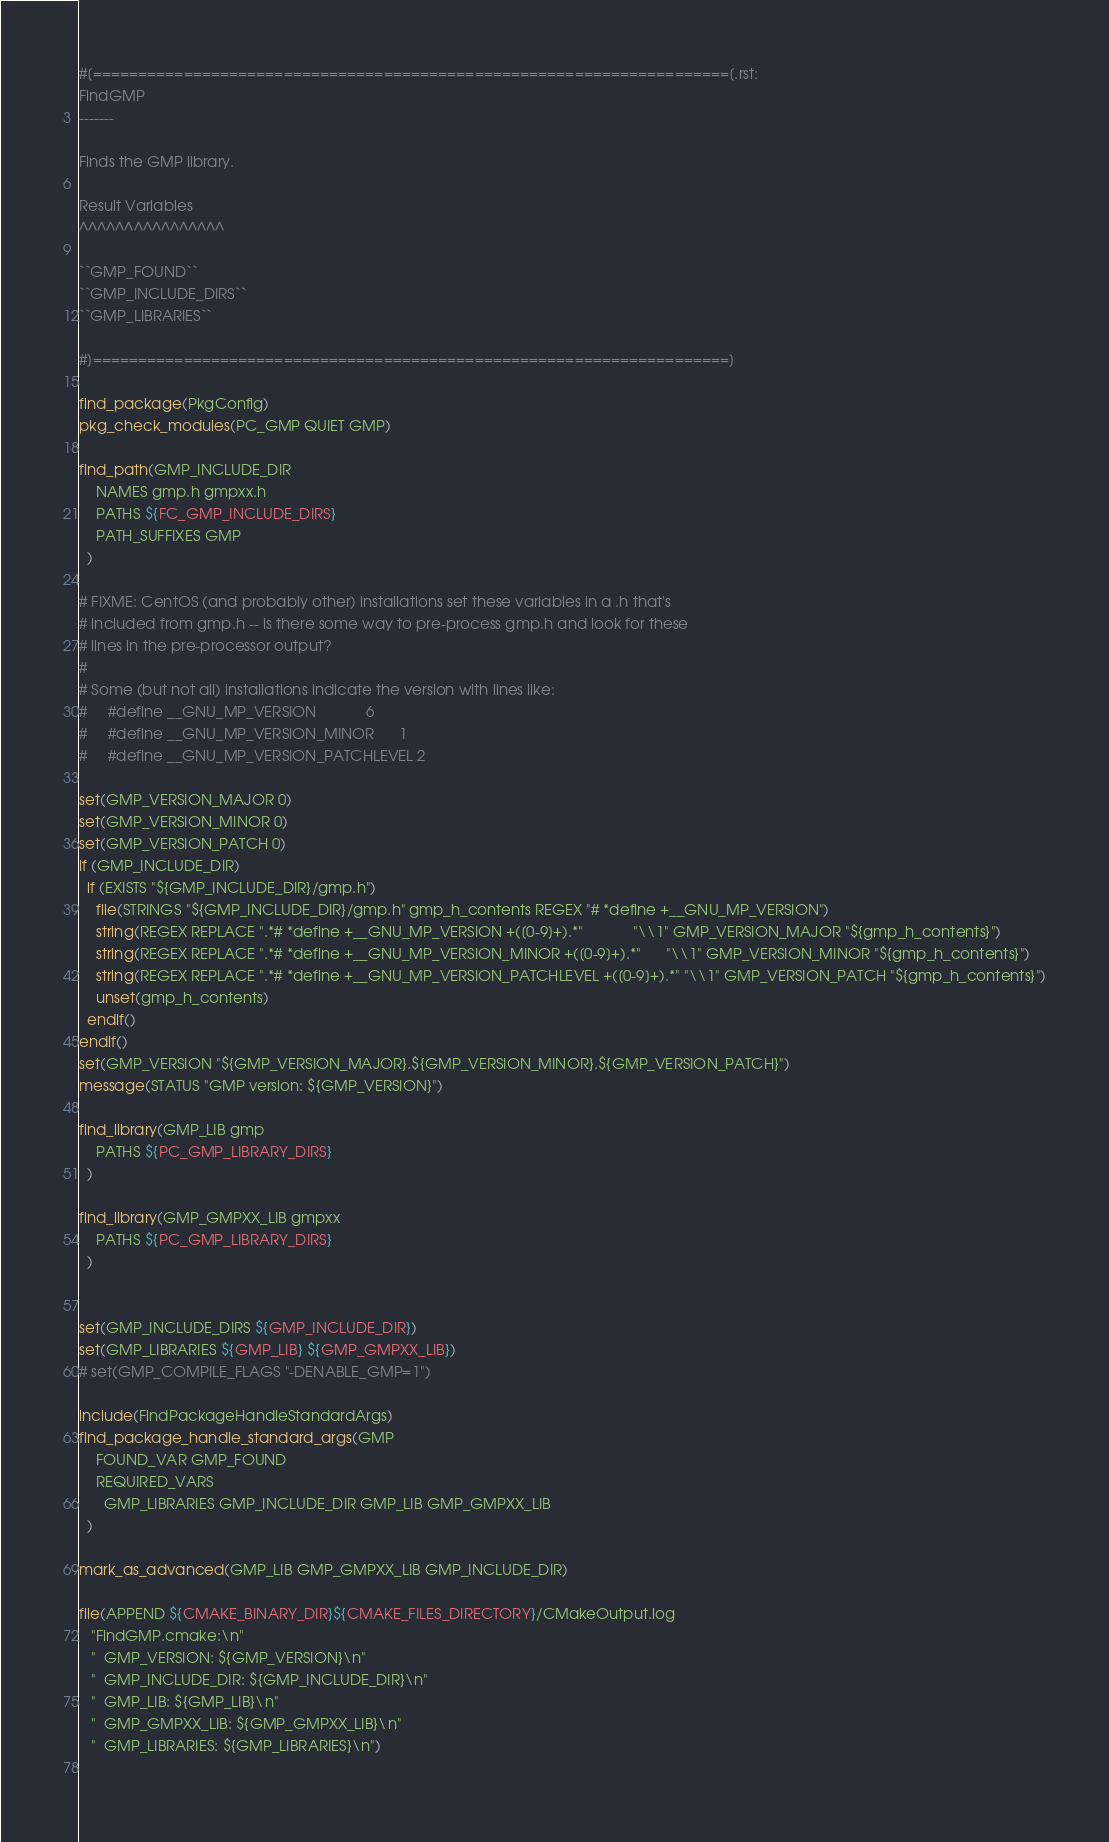Convert code to text. <code><loc_0><loc_0><loc_500><loc_500><_CMake_>#[======================================================================[.rst:
FindGMP
-------

Finds the GMP library.

Result Variables
^^^^^^^^^^^^^^^^

``GMP_FOUND``
``GMP_INCLUDE_DIRS``
``GMP_LIBRARIES``

#]======================================================================]

find_package(PkgConfig)
pkg_check_modules(PC_GMP QUIET GMP)

find_path(GMP_INCLUDE_DIR
    NAMES gmp.h gmpxx.h
    PATHS ${FC_GMP_INCLUDE_DIRS}
    PATH_SUFFIXES GMP
  )

# FIXME: CentOS (and probably other) installations set these variables in a .h that's
# included from gmp.h -- is there some way to pre-process gmp.h and look for these
# lines in the pre-processor output?
#
# Some (but not all) installations indicate the version with lines like:
#     #define __GNU_MP_VERSION            6
#     #define __GNU_MP_VERSION_MINOR      1
#     #define __GNU_MP_VERSION_PATCHLEVEL 2

set(GMP_VERSION_MAJOR 0)
set(GMP_VERSION_MINOR 0)
set(GMP_VERSION_PATCH 0)
if (GMP_INCLUDE_DIR)
  if (EXISTS "${GMP_INCLUDE_DIR}/gmp.h")
    file(STRINGS "${GMP_INCLUDE_DIR}/gmp.h" gmp_h_contents REGEX "# *define +__GNU_MP_VERSION")
    string(REGEX REPLACE ".*# *define +__GNU_MP_VERSION +([0-9]+).*"            "\\1" GMP_VERSION_MAJOR "${gmp_h_contents}")
    string(REGEX REPLACE ".*# *define +__GNU_MP_VERSION_MINOR +([0-9]+).*"      "\\1" GMP_VERSION_MINOR "${gmp_h_contents}")
    string(REGEX REPLACE ".*# *define +__GNU_MP_VERSION_PATCHLEVEL +([0-9]+).*" "\\1" GMP_VERSION_PATCH "${gmp_h_contents}")
    unset(gmp_h_contents)
  endif()
endif()
set(GMP_VERSION "${GMP_VERSION_MAJOR}.${GMP_VERSION_MINOR}.${GMP_VERSION_PATCH}")
message(STATUS "GMP version: ${GMP_VERSION}")

find_library(GMP_LIB gmp
    PATHS ${PC_GMP_LIBRARY_DIRS}
  )

find_library(GMP_GMPXX_LIB gmpxx
    PATHS ${PC_GMP_LIBRARY_DIRS}
  )


set(GMP_INCLUDE_DIRS ${GMP_INCLUDE_DIR})
set(GMP_LIBRARIES ${GMP_LIB} ${GMP_GMPXX_LIB})
# set(GMP_COMPILE_FLAGS "-DENABLE_GMP=1")

include(FindPackageHandleStandardArgs)
find_package_handle_standard_args(GMP
    FOUND_VAR GMP_FOUND
    REQUIRED_VARS
      GMP_LIBRARIES GMP_INCLUDE_DIR GMP_LIB GMP_GMPXX_LIB
  )

mark_as_advanced(GMP_LIB GMP_GMPXX_LIB GMP_INCLUDE_DIR)

file(APPEND ${CMAKE_BINARY_DIR}${CMAKE_FILES_DIRECTORY}/CMakeOutput.log
   "FindGMP.cmake:\n"
   "  GMP_VERSION: ${GMP_VERSION}\n"
   "  GMP_INCLUDE_DIR: ${GMP_INCLUDE_DIR}\n"
   "  GMP_LIB: ${GMP_LIB}\n"
   "  GMP_GMPXX_LIB: ${GMP_GMPXX_LIB}\n"
   "  GMP_LIBRARIES: ${GMP_LIBRARIES}\n")
   


</code> 